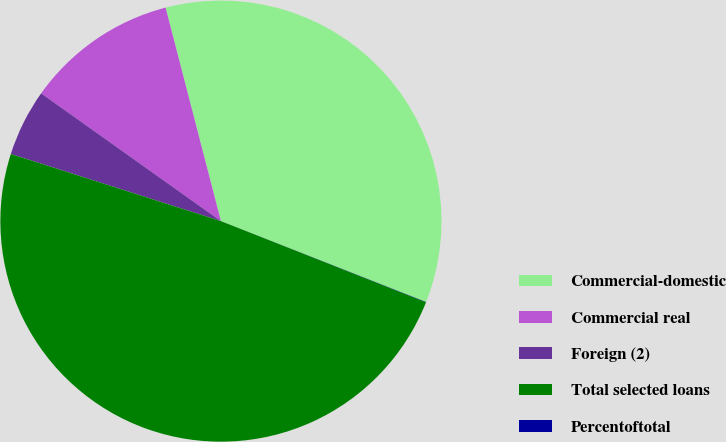<chart> <loc_0><loc_0><loc_500><loc_500><pie_chart><fcel>Commercial-domestic<fcel>Commercial real<fcel>Foreign (2)<fcel>Total selected loans<fcel>Percentoftotal<nl><fcel>35.01%<fcel>11.13%<fcel>4.91%<fcel>48.93%<fcel>0.02%<nl></chart> 